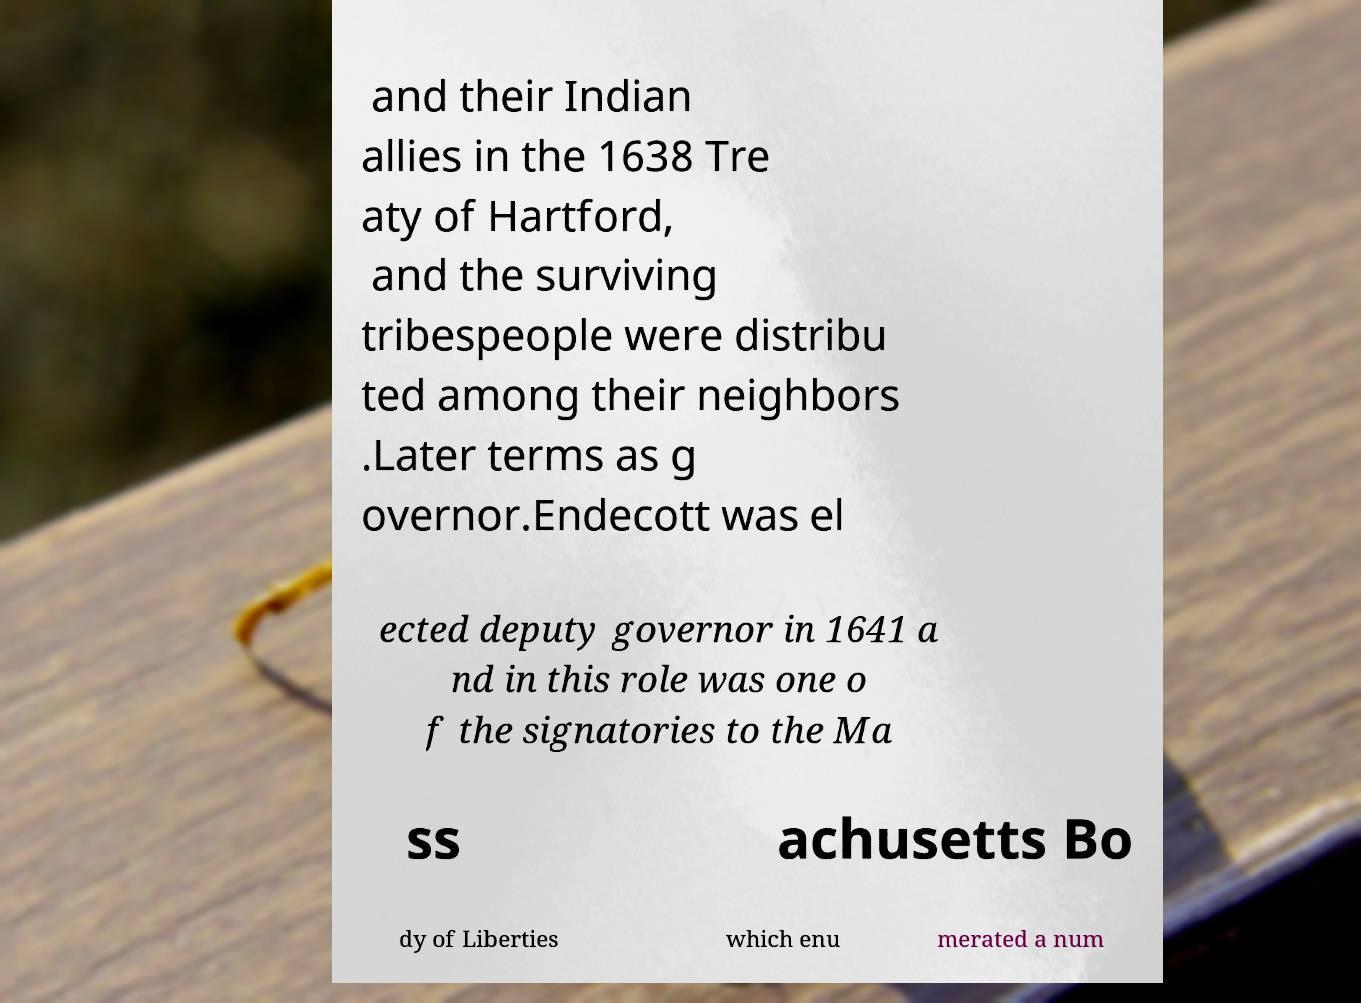Can you read and provide the text displayed in the image?This photo seems to have some interesting text. Can you extract and type it out for me? and their Indian allies in the 1638 Tre aty of Hartford, and the surviving tribespeople were distribu ted among their neighbors .Later terms as g overnor.Endecott was el ected deputy governor in 1641 a nd in this role was one o f the signatories to the Ma ss achusetts Bo dy of Liberties which enu merated a num 